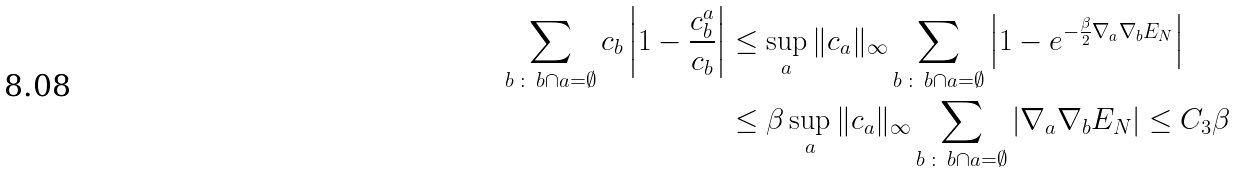Convert formula to latex. <formula><loc_0><loc_0><loc_500><loc_500>\sum _ { b \, \colon \, b \cap a = \emptyset } c _ { b } \left | 1 - \frac { c _ { b } ^ { a } } { c _ { b } } \right | & \leq \sup _ { a } \| c _ { a } \| _ { \infty } \sum _ { b \, \colon \, b \cap a = \emptyset } \left | 1 - e ^ { - \frac { \beta } { 2 } \nabla _ { a } \nabla _ { b } E _ { N } } \right | \\ & \leq \beta \sup _ { a } \| c _ { a } \| _ { \infty } \sum _ { b \, \colon \, b \cap a = \emptyset } \left | \nabla _ { a } \nabla _ { b } E _ { N } \right | \leq C _ { 3 } \beta</formula> 